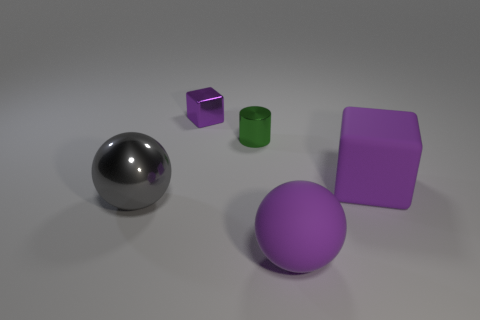What shape is the matte object that is the same color as the rubber sphere?
Provide a short and direct response. Cube. Is the material of the large purple thing in front of the big purple matte block the same as the tiny thing that is behind the small metallic cylinder?
Offer a terse response. No. Are there the same number of big purple rubber balls that are in front of the tiny purple shiny block and metallic cubes that are in front of the rubber ball?
Provide a short and direct response. No. What is the color of the matte sphere that is the same size as the gray shiny object?
Offer a terse response. Purple. Are there any matte objects of the same color as the small block?
Your answer should be compact. Yes. What number of objects are either purple blocks in front of the small green metal cylinder or large cyan matte blocks?
Your answer should be very brief. 1. How many other things are the same size as the metallic sphere?
Give a very brief answer. 2. The big ball that is on the right side of the large object that is on the left side of the ball on the right side of the green metal object is made of what material?
Offer a terse response. Rubber. What number of blocks are either rubber objects or small metallic things?
Give a very brief answer. 2. Are there any other things that are the same shape as the tiny green metal thing?
Provide a succinct answer. No. 